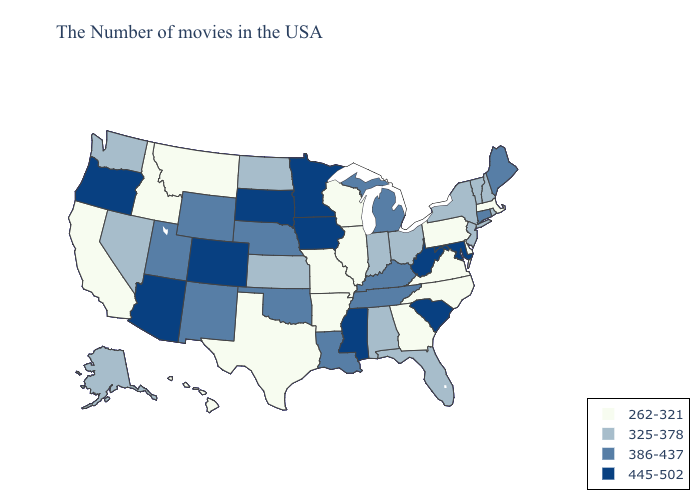Does West Virginia have a lower value than Montana?
Give a very brief answer. No. Which states hav the highest value in the South?
Give a very brief answer. Maryland, South Carolina, West Virginia, Mississippi. What is the highest value in states that border Arkansas?
Answer briefly. 445-502. Does Maine have the highest value in the USA?
Quick response, please. No. Name the states that have a value in the range 262-321?
Short answer required. Massachusetts, Delaware, Pennsylvania, Virginia, North Carolina, Georgia, Wisconsin, Illinois, Missouri, Arkansas, Texas, Montana, Idaho, California, Hawaii. Among the states that border Alabama , does Georgia have the lowest value?
Concise answer only. Yes. What is the value of Oregon?
Write a very short answer. 445-502. Name the states that have a value in the range 262-321?
Keep it brief. Massachusetts, Delaware, Pennsylvania, Virginia, North Carolina, Georgia, Wisconsin, Illinois, Missouri, Arkansas, Texas, Montana, Idaho, California, Hawaii. Which states have the lowest value in the USA?
Concise answer only. Massachusetts, Delaware, Pennsylvania, Virginia, North Carolina, Georgia, Wisconsin, Illinois, Missouri, Arkansas, Texas, Montana, Idaho, California, Hawaii. Is the legend a continuous bar?
Concise answer only. No. What is the value of Tennessee?
Write a very short answer. 386-437. Which states hav the highest value in the South?
Give a very brief answer. Maryland, South Carolina, West Virginia, Mississippi. How many symbols are there in the legend?
Answer briefly. 4. What is the value of Maryland?
Answer briefly. 445-502. What is the value of Oregon?
Be succinct. 445-502. 